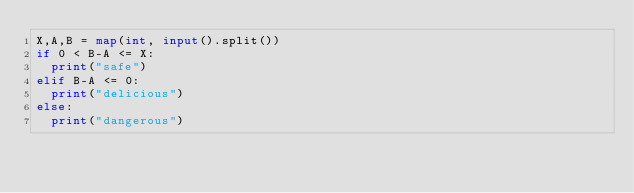Convert code to text. <code><loc_0><loc_0><loc_500><loc_500><_Python_>X,A,B = map(int, input().split())
if 0 < B-A <= X:
  print("safe")
elif B-A <= 0:
  print("delicious")
else:
  print("dangerous")
</code> 